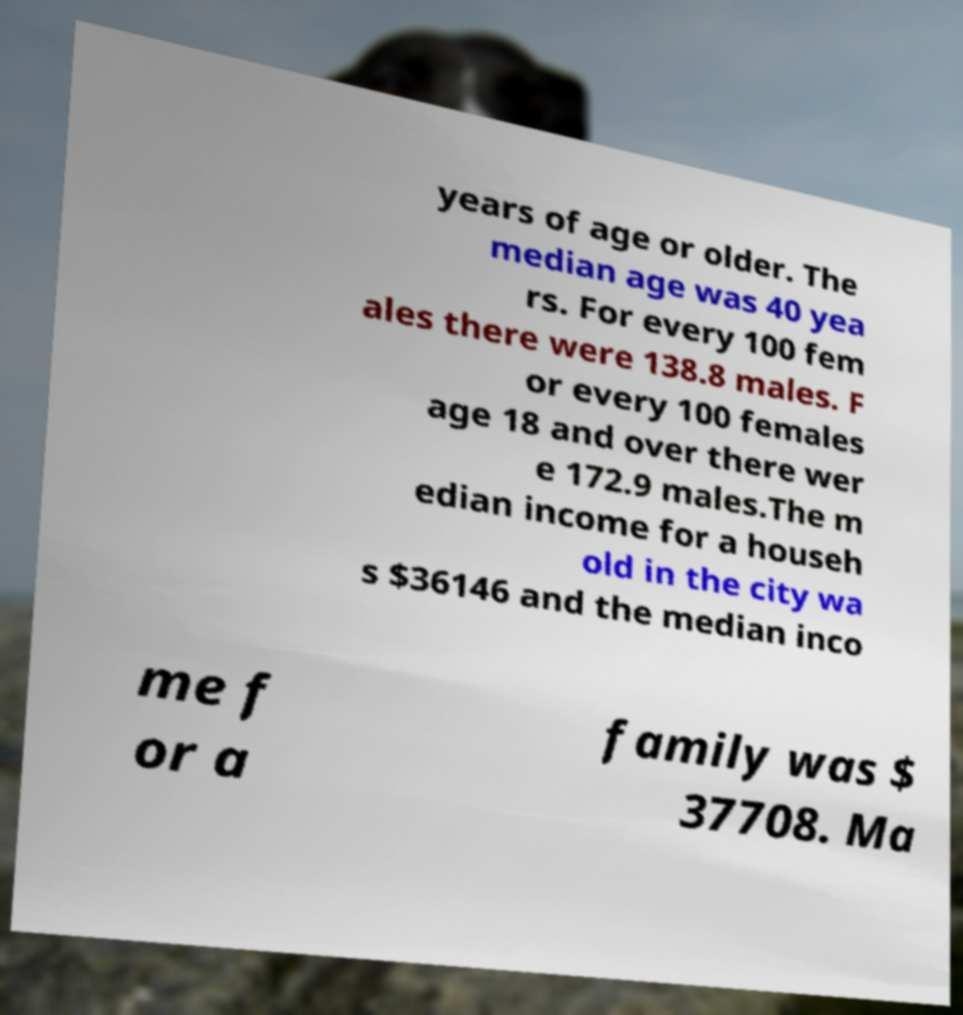Can you read and provide the text displayed in the image?This photo seems to have some interesting text. Can you extract and type it out for me? years of age or older. The median age was 40 yea rs. For every 100 fem ales there were 138.8 males. F or every 100 females age 18 and over there wer e 172.9 males.The m edian income for a househ old in the city wa s $36146 and the median inco me f or a family was $ 37708. Ma 